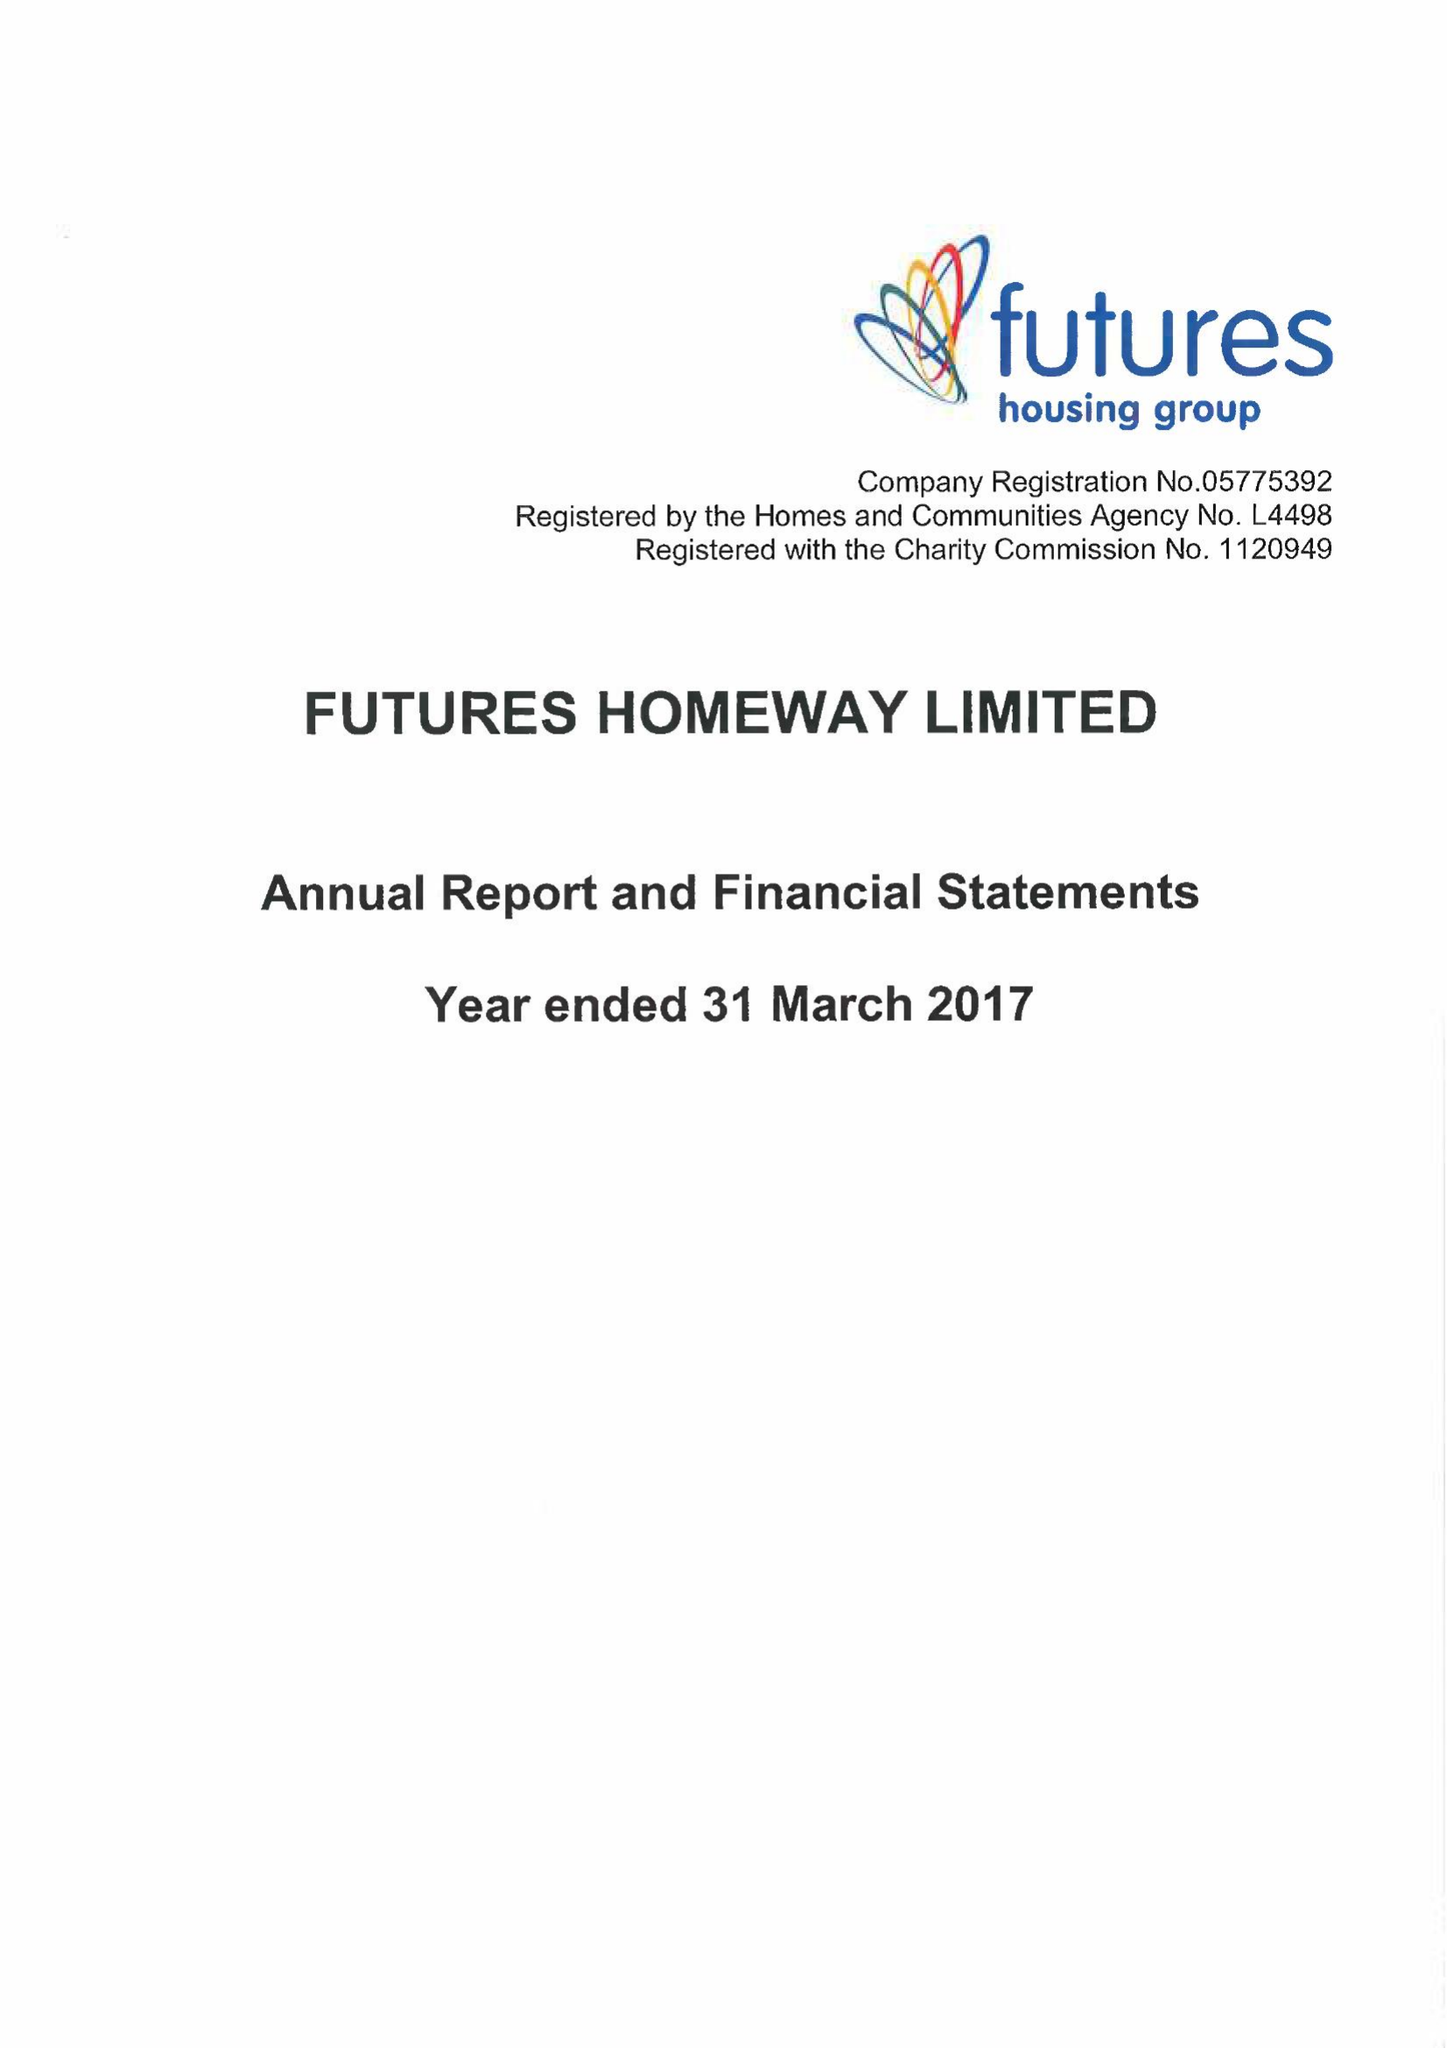What is the value for the address__post_town?
Answer the question using a single word or phrase. RIPLEY 